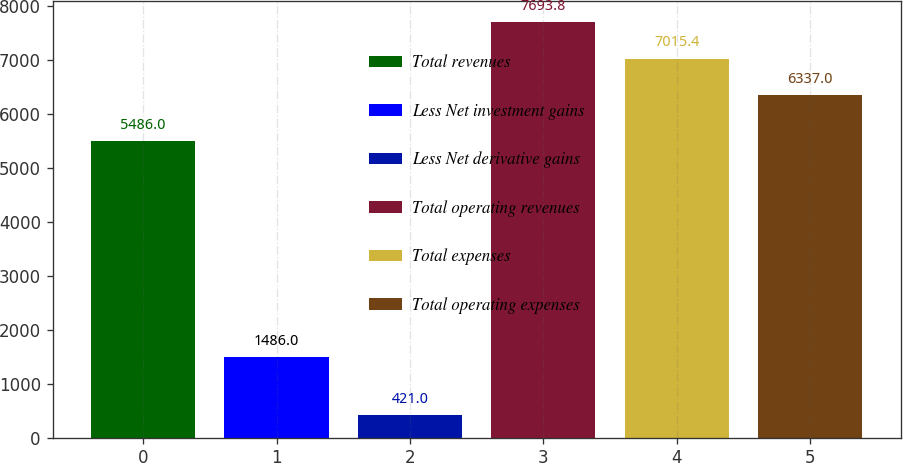Convert chart. <chart><loc_0><loc_0><loc_500><loc_500><bar_chart><fcel>Total revenues<fcel>Less Net investment gains<fcel>Less Net derivative gains<fcel>Total operating revenues<fcel>Total expenses<fcel>Total operating expenses<nl><fcel>5486<fcel>1486<fcel>421<fcel>7693.8<fcel>7015.4<fcel>6337<nl></chart> 